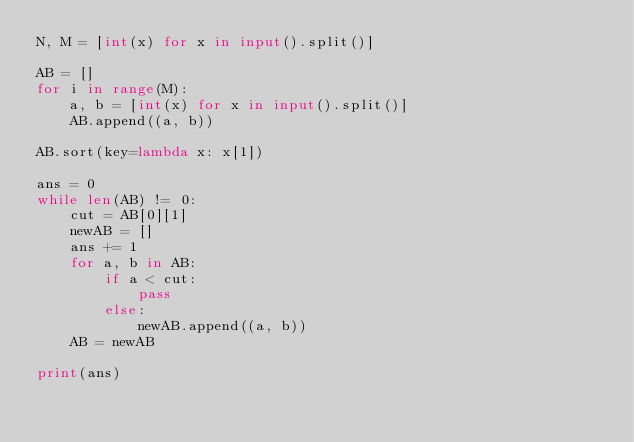<code> <loc_0><loc_0><loc_500><loc_500><_Python_>N, M = [int(x) for x in input().split()]

AB = []
for i in range(M):
    a, b = [int(x) for x in input().split()]
    AB.append((a, b))

AB.sort(key=lambda x: x[1])

ans = 0
while len(AB) != 0:
    cut = AB[0][1]
    newAB = []
    ans += 1
    for a, b in AB:
        if a < cut:
            pass
        else:
            newAB.append((a, b))
    AB = newAB

print(ans)
</code> 